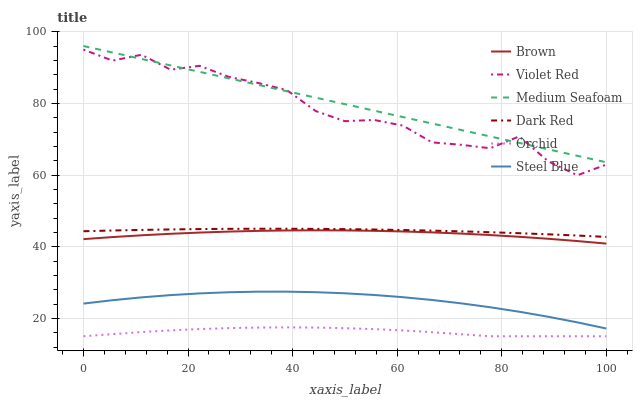Does Violet Red have the minimum area under the curve?
Answer yes or no. No. Does Violet Red have the maximum area under the curve?
Answer yes or no. No. Is Dark Red the smoothest?
Answer yes or no. No. Is Dark Red the roughest?
Answer yes or no. No. Does Violet Red have the lowest value?
Answer yes or no. No. Does Violet Red have the highest value?
Answer yes or no. No. Is Brown less than Medium Seafoam?
Answer yes or no. Yes. Is Violet Red greater than Orchid?
Answer yes or no. Yes. Does Brown intersect Medium Seafoam?
Answer yes or no. No. 